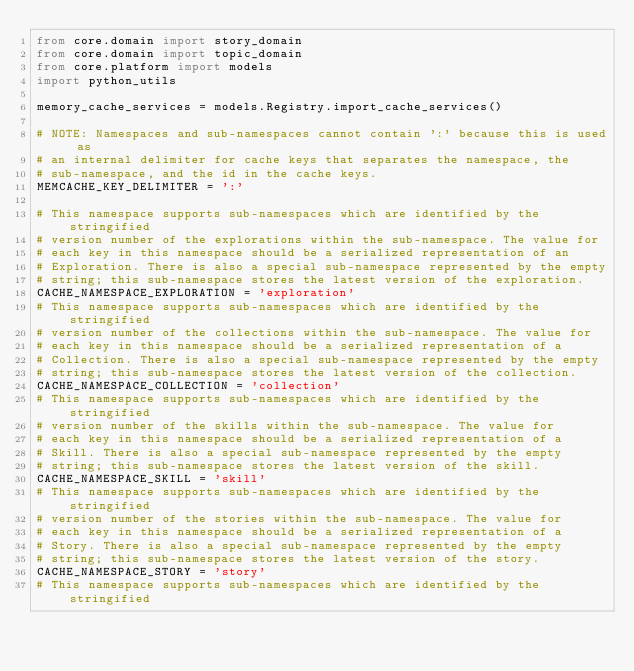Convert code to text. <code><loc_0><loc_0><loc_500><loc_500><_Python_>from core.domain import story_domain
from core.domain import topic_domain
from core.platform import models
import python_utils

memory_cache_services = models.Registry.import_cache_services()

# NOTE: Namespaces and sub-namespaces cannot contain ':' because this is used as
# an internal delimiter for cache keys that separates the namespace, the
# sub-namespace, and the id in the cache keys.
MEMCACHE_KEY_DELIMITER = ':'

# This namespace supports sub-namespaces which are identified by the stringified
# version number of the explorations within the sub-namespace. The value for
# each key in this namespace should be a serialized representation of an
# Exploration. There is also a special sub-namespace represented by the empty
# string; this sub-namespace stores the latest version of the exploration.
CACHE_NAMESPACE_EXPLORATION = 'exploration'
# This namespace supports sub-namespaces which are identified by the stringified
# version number of the collections within the sub-namespace. The value for
# each key in this namespace should be a serialized representation of a
# Collection. There is also a special sub-namespace represented by the empty
# string; this sub-namespace stores the latest version of the collection.
CACHE_NAMESPACE_COLLECTION = 'collection'
# This namespace supports sub-namespaces which are identified by the stringified
# version number of the skills within the sub-namespace. The value for
# each key in this namespace should be a serialized representation of a
# Skill. There is also a special sub-namespace represented by the empty
# string; this sub-namespace stores the latest version of the skill.
CACHE_NAMESPACE_SKILL = 'skill'
# This namespace supports sub-namespaces which are identified by the stringified
# version number of the stories within the sub-namespace. The value for
# each key in this namespace should be a serialized representation of a
# Story. There is also a special sub-namespace represented by the empty
# string; this sub-namespace stores the latest version of the story.
CACHE_NAMESPACE_STORY = 'story'
# This namespace supports sub-namespaces which are identified by the stringified</code> 